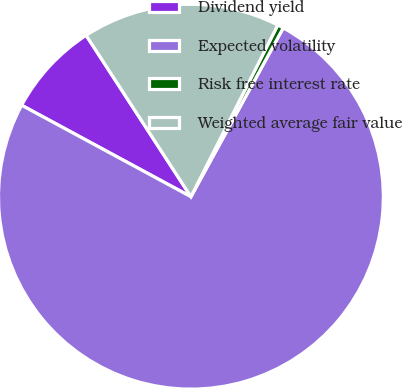<chart> <loc_0><loc_0><loc_500><loc_500><pie_chart><fcel>Dividend yield<fcel>Expected volatility<fcel>Risk free interest rate<fcel>Weighted average fair value<nl><fcel>7.95%<fcel>74.92%<fcel>0.51%<fcel>16.62%<nl></chart> 